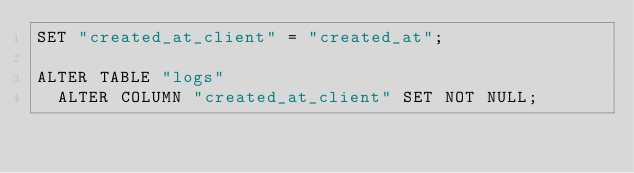Convert code to text. <code><loc_0><loc_0><loc_500><loc_500><_SQL_>SET "created_at_client" = "created_at";

ALTER TABLE "logs"
  ALTER COLUMN "created_at_client" SET NOT NULL;
</code> 